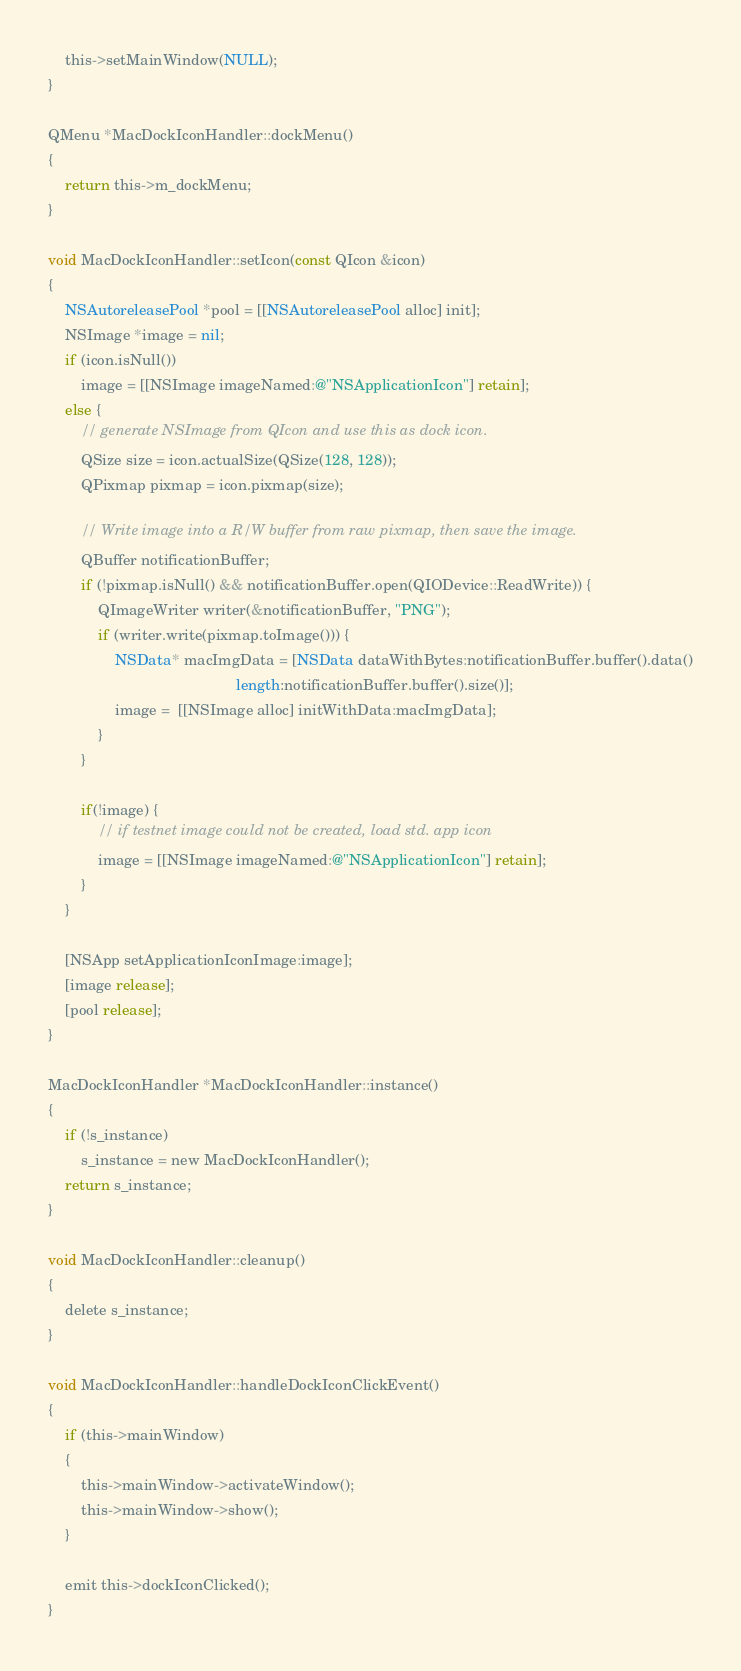Convert code to text. <code><loc_0><loc_0><loc_500><loc_500><_ObjectiveC_>    this->setMainWindow(NULL);
}

QMenu *MacDockIconHandler::dockMenu()
{
    return this->m_dockMenu;
}

void MacDockIconHandler::setIcon(const QIcon &icon)
{
    NSAutoreleasePool *pool = [[NSAutoreleasePool alloc] init];
    NSImage *image = nil;
    if (icon.isNull())
        image = [[NSImage imageNamed:@"NSApplicationIcon"] retain];
    else {
        // generate NSImage from QIcon and use this as dock icon.
        QSize size = icon.actualSize(QSize(128, 128));
        QPixmap pixmap = icon.pixmap(size);

        // Write image into a R/W buffer from raw pixmap, then save the image.
        QBuffer notificationBuffer;
        if (!pixmap.isNull() && notificationBuffer.open(QIODevice::ReadWrite)) {
            QImageWriter writer(&notificationBuffer, "PNG");
            if (writer.write(pixmap.toImage())) {
                NSData* macImgData = [NSData dataWithBytes:notificationBuffer.buffer().data()
                                             length:notificationBuffer.buffer().size()];
                image =  [[NSImage alloc] initWithData:macImgData];
            }
        }

        if(!image) {
            // if testnet image could not be created, load std. app icon
            image = [[NSImage imageNamed:@"NSApplicationIcon"] retain];
        }
    }

    [NSApp setApplicationIconImage:image];
    [image release];
    [pool release];
}

MacDockIconHandler *MacDockIconHandler::instance()
{
    if (!s_instance)
        s_instance = new MacDockIconHandler();
    return s_instance;
}

void MacDockIconHandler::cleanup()
{
    delete s_instance;
}

void MacDockIconHandler::handleDockIconClickEvent()
{
    if (this->mainWindow)
    {
        this->mainWindow->activateWindow();
        this->mainWindow->show();
    }

    emit this->dockIconClicked();
}
</code> 